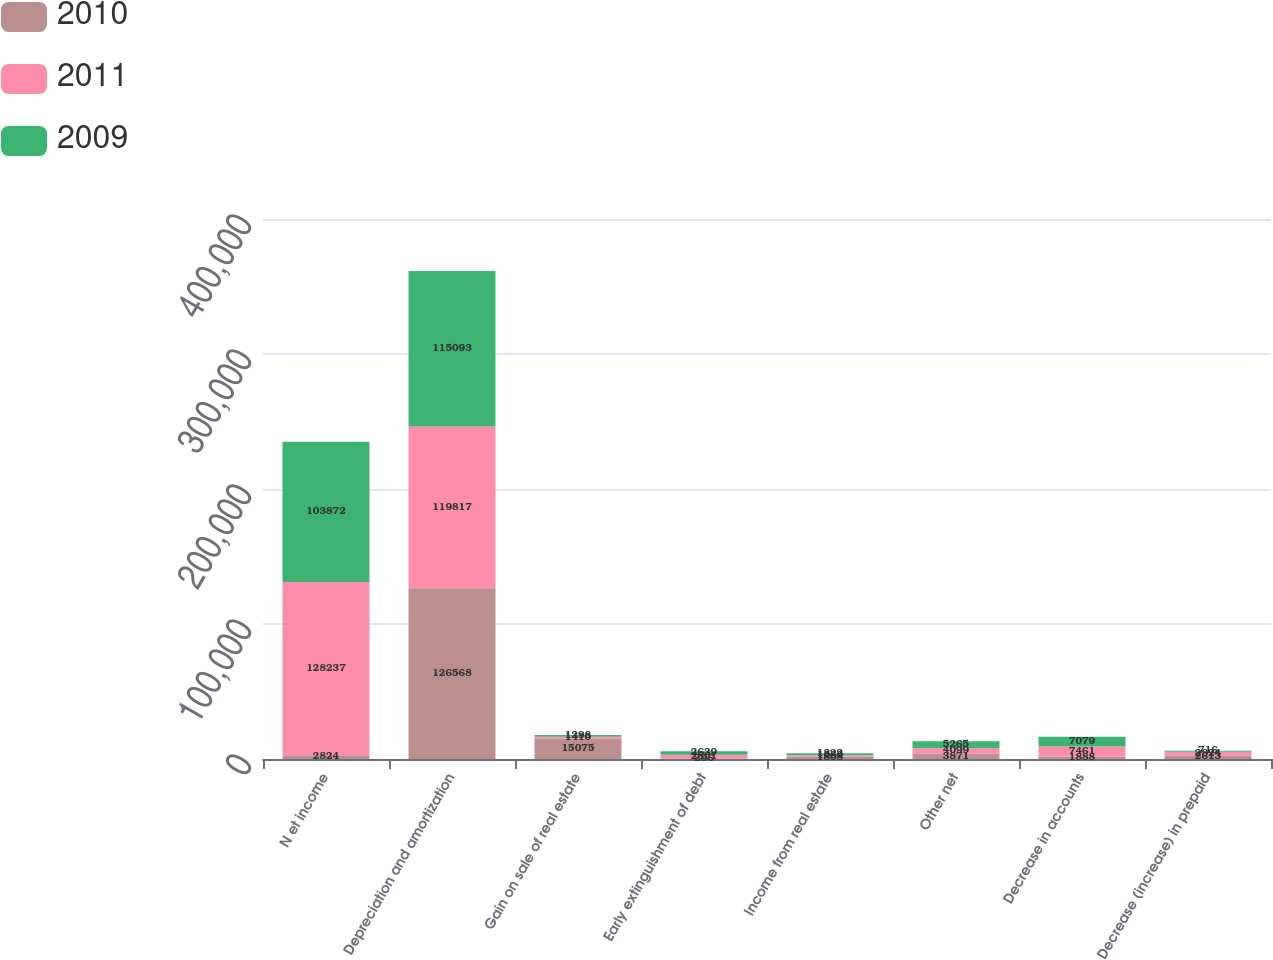Convert chart to OTSL. <chart><loc_0><loc_0><loc_500><loc_500><stacked_bar_chart><ecel><fcel>N et income<fcel>Depreciation and amortization<fcel>Gain on sale of real estate<fcel>Early extinguishment of debt<fcel>Income from real estate<fcel>Other net<fcel>Decrease in accounts<fcel>Decrease (increase) in prepaid<nl><fcel>2010<fcel>2824<fcel>126568<fcel>15075<fcel>296<fcel>1808<fcel>3871<fcel>1888<fcel>2613<nl><fcel>2011<fcel>128237<fcel>119817<fcel>1410<fcel>2801<fcel>1060<fcel>4099<fcel>7461<fcel>2824<nl><fcel>2009<fcel>103872<fcel>115093<fcel>1298<fcel>2639<fcel>1322<fcel>5265<fcel>7079<fcel>716<nl></chart> 